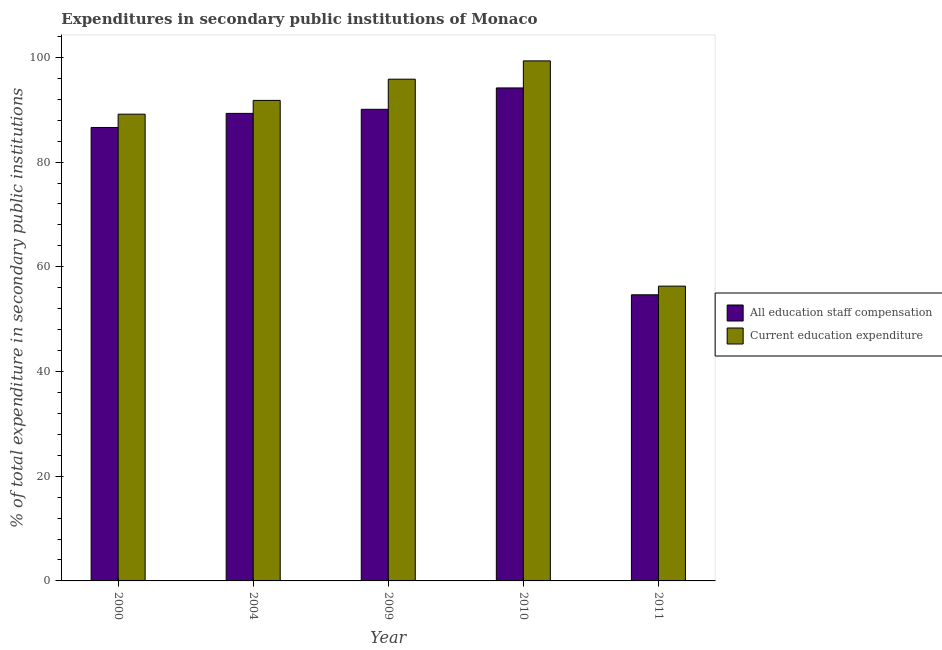How many different coloured bars are there?
Offer a terse response. 2. Are the number of bars per tick equal to the number of legend labels?
Offer a very short reply. Yes. What is the label of the 2nd group of bars from the left?
Make the answer very short. 2004. What is the expenditure in education in 2010?
Ensure brevity in your answer.  99.34. Across all years, what is the maximum expenditure in education?
Ensure brevity in your answer.  99.34. Across all years, what is the minimum expenditure in staff compensation?
Give a very brief answer. 54.66. In which year was the expenditure in staff compensation maximum?
Offer a very short reply. 2010. In which year was the expenditure in education minimum?
Provide a succinct answer. 2011. What is the total expenditure in staff compensation in the graph?
Offer a terse response. 414.84. What is the difference between the expenditure in staff compensation in 2009 and that in 2011?
Provide a succinct answer. 35.43. What is the difference between the expenditure in staff compensation in 2011 and the expenditure in education in 2009?
Provide a succinct answer. -35.43. What is the average expenditure in staff compensation per year?
Offer a terse response. 82.97. What is the ratio of the expenditure in staff compensation in 2000 to that in 2009?
Your answer should be compact. 0.96. Is the expenditure in staff compensation in 2004 less than that in 2011?
Make the answer very short. No. Is the difference between the expenditure in staff compensation in 2000 and 2004 greater than the difference between the expenditure in education in 2000 and 2004?
Provide a succinct answer. No. What is the difference between the highest and the second highest expenditure in education?
Offer a terse response. 3.5. What is the difference between the highest and the lowest expenditure in education?
Provide a short and direct response. 43.03. What does the 2nd bar from the left in 2011 represents?
Offer a very short reply. Current education expenditure. What does the 2nd bar from the right in 2009 represents?
Your answer should be very brief. All education staff compensation. How many bars are there?
Your response must be concise. 10. How many years are there in the graph?
Ensure brevity in your answer.  5. What is the difference between two consecutive major ticks on the Y-axis?
Offer a very short reply. 20. Are the values on the major ticks of Y-axis written in scientific E-notation?
Provide a succinct answer. No. Does the graph contain any zero values?
Make the answer very short. No. Does the graph contain grids?
Provide a succinct answer. No. Where does the legend appear in the graph?
Your answer should be very brief. Center right. How many legend labels are there?
Provide a succinct answer. 2. What is the title of the graph?
Offer a very short reply. Expenditures in secondary public institutions of Monaco. Does "Central government" appear as one of the legend labels in the graph?
Provide a succinct answer. No. What is the label or title of the X-axis?
Your answer should be very brief. Year. What is the label or title of the Y-axis?
Your answer should be compact. % of total expenditure in secondary public institutions. What is the % of total expenditure in secondary public institutions in All education staff compensation in 2000?
Provide a short and direct response. 86.62. What is the % of total expenditure in secondary public institutions of Current education expenditure in 2000?
Make the answer very short. 89.16. What is the % of total expenditure in secondary public institutions in All education staff compensation in 2004?
Provide a succinct answer. 89.31. What is the % of total expenditure in secondary public institutions of Current education expenditure in 2004?
Your answer should be compact. 91.79. What is the % of total expenditure in secondary public institutions in All education staff compensation in 2009?
Your response must be concise. 90.09. What is the % of total expenditure in secondary public institutions in Current education expenditure in 2009?
Offer a very short reply. 95.84. What is the % of total expenditure in secondary public institutions of All education staff compensation in 2010?
Provide a short and direct response. 94.17. What is the % of total expenditure in secondary public institutions of Current education expenditure in 2010?
Ensure brevity in your answer.  99.34. What is the % of total expenditure in secondary public institutions of All education staff compensation in 2011?
Offer a very short reply. 54.66. What is the % of total expenditure in secondary public institutions of Current education expenditure in 2011?
Give a very brief answer. 56.31. Across all years, what is the maximum % of total expenditure in secondary public institutions in All education staff compensation?
Your answer should be very brief. 94.17. Across all years, what is the maximum % of total expenditure in secondary public institutions in Current education expenditure?
Offer a terse response. 99.34. Across all years, what is the minimum % of total expenditure in secondary public institutions of All education staff compensation?
Provide a short and direct response. 54.66. Across all years, what is the minimum % of total expenditure in secondary public institutions of Current education expenditure?
Your answer should be compact. 56.31. What is the total % of total expenditure in secondary public institutions in All education staff compensation in the graph?
Offer a very short reply. 414.84. What is the total % of total expenditure in secondary public institutions in Current education expenditure in the graph?
Make the answer very short. 432.44. What is the difference between the % of total expenditure in secondary public institutions in All education staff compensation in 2000 and that in 2004?
Make the answer very short. -2.69. What is the difference between the % of total expenditure in secondary public institutions of Current education expenditure in 2000 and that in 2004?
Your answer should be compact. -2.63. What is the difference between the % of total expenditure in secondary public institutions in All education staff compensation in 2000 and that in 2009?
Offer a very short reply. -3.47. What is the difference between the % of total expenditure in secondary public institutions of Current education expenditure in 2000 and that in 2009?
Keep it short and to the point. -6.68. What is the difference between the % of total expenditure in secondary public institutions of All education staff compensation in 2000 and that in 2010?
Offer a terse response. -7.55. What is the difference between the % of total expenditure in secondary public institutions in Current education expenditure in 2000 and that in 2010?
Give a very brief answer. -10.18. What is the difference between the % of total expenditure in secondary public institutions in All education staff compensation in 2000 and that in 2011?
Provide a succinct answer. 31.96. What is the difference between the % of total expenditure in secondary public institutions of Current education expenditure in 2000 and that in 2011?
Give a very brief answer. 32.85. What is the difference between the % of total expenditure in secondary public institutions of All education staff compensation in 2004 and that in 2009?
Offer a very short reply. -0.78. What is the difference between the % of total expenditure in secondary public institutions of Current education expenditure in 2004 and that in 2009?
Keep it short and to the point. -4.05. What is the difference between the % of total expenditure in secondary public institutions in All education staff compensation in 2004 and that in 2010?
Ensure brevity in your answer.  -4.86. What is the difference between the % of total expenditure in secondary public institutions of Current education expenditure in 2004 and that in 2010?
Ensure brevity in your answer.  -7.55. What is the difference between the % of total expenditure in secondary public institutions in All education staff compensation in 2004 and that in 2011?
Offer a very short reply. 34.65. What is the difference between the % of total expenditure in secondary public institutions of Current education expenditure in 2004 and that in 2011?
Offer a terse response. 35.48. What is the difference between the % of total expenditure in secondary public institutions in All education staff compensation in 2009 and that in 2010?
Provide a short and direct response. -4.08. What is the difference between the % of total expenditure in secondary public institutions in Current education expenditure in 2009 and that in 2010?
Make the answer very short. -3.5. What is the difference between the % of total expenditure in secondary public institutions of All education staff compensation in 2009 and that in 2011?
Make the answer very short. 35.43. What is the difference between the % of total expenditure in secondary public institutions of Current education expenditure in 2009 and that in 2011?
Offer a very short reply. 39.53. What is the difference between the % of total expenditure in secondary public institutions in All education staff compensation in 2010 and that in 2011?
Provide a succinct answer. 39.51. What is the difference between the % of total expenditure in secondary public institutions of Current education expenditure in 2010 and that in 2011?
Offer a very short reply. 43.03. What is the difference between the % of total expenditure in secondary public institutions in All education staff compensation in 2000 and the % of total expenditure in secondary public institutions in Current education expenditure in 2004?
Give a very brief answer. -5.17. What is the difference between the % of total expenditure in secondary public institutions of All education staff compensation in 2000 and the % of total expenditure in secondary public institutions of Current education expenditure in 2009?
Offer a terse response. -9.23. What is the difference between the % of total expenditure in secondary public institutions of All education staff compensation in 2000 and the % of total expenditure in secondary public institutions of Current education expenditure in 2010?
Offer a terse response. -12.72. What is the difference between the % of total expenditure in secondary public institutions of All education staff compensation in 2000 and the % of total expenditure in secondary public institutions of Current education expenditure in 2011?
Make the answer very short. 30.31. What is the difference between the % of total expenditure in secondary public institutions of All education staff compensation in 2004 and the % of total expenditure in secondary public institutions of Current education expenditure in 2009?
Your answer should be very brief. -6.53. What is the difference between the % of total expenditure in secondary public institutions of All education staff compensation in 2004 and the % of total expenditure in secondary public institutions of Current education expenditure in 2010?
Provide a succinct answer. -10.03. What is the difference between the % of total expenditure in secondary public institutions in All education staff compensation in 2004 and the % of total expenditure in secondary public institutions in Current education expenditure in 2011?
Offer a very short reply. 33. What is the difference between the % of total expenditure in secondary public institutions of All education staff compensation in 2009 and the % of total expenditure in secondary public institutions of Current education expenditure in 2010?
Your answer should be compact. -9.25. What is the difference between the % of total expenditure in secondary public institutions of All education staff compensation in 2009 and the % of total expenditure in secondary public institutions of Current education expenditure in 2011?
Provide a succinct answer. 33.78. What is the difference between the % of total expenditure in secondary public institutions of All education staff compensation in 2010 and the % of total expenditure in secondary public institutions of Current education expenditure in 2011?
Give a very brief answer. 37.86. What is the average % of total expenditure in secondary public institutions of All education staff compensation per year?
Your response must be concise. 82.97. What is the average % of total expenditure in secondary public institutions of Current education expenditure per year?
Your response must be concise. 86.49. In the year 2000, what is the difference between the % of total expenditure in secondary public institutions in All education staff compensation and % of total expenditure in secondary public institutions in Current education expenditure?
Provide a succinct answer. -2.54. In the year 2004, what is the difference between the % of total expenditure in secondary public institutions of All education staff compensation and % of total expenditure in secondary public institutions of Current education expenditure?
Offer a very short reply. -2.48. In the year 2009, what is the difference between the % of total expenditure in secondary public institutions of All education staff compensation and % of total expenditure in secondary public institutions of Current education expenditure?
Provide a succinct answer. -5.75. In the year 2010, what is the difference between the % of total expenditure in secondary public institutions of All education staff compensation and % of total expenditure in secondary public institutions of Current education expenditure?
Offer a terse response. -5.17. In the year 2011, what is the difference between the % of total expenditure in secondary public institutions in All education staff compensation and % of total expenditure in secondary public institutions in Current education expenditure?
Give a very brief answer. -1.65. What is the ratio of the % of total expenditure in secondary public institutions of All education staff compensation in 2000 to that in 2004?
Make the answer very short. 0.97. What is the ratio of the % of total expenditure in secondary public institutions of Current education expenditure in 2000 to that in 2004?
Offer a terse response. 0.97. What is the ratio of the % of total expenditure in secondary public institutions in All education staff compensation in 2000 to that in 2009?
Your answer should be very brief. 0.96. What is the ratio of the % of total expenditure in secondary public institutions of Current education expenditure in 2000 to that in 2009?
Your response must be concise. 0.93. What is the ratio of the % of total expenditure in secondary public institutions of All education staff compensation in 2000 to that in 2010?
Give a very brief answer. 0.92. What is the ratio of the % of total expenditure in secondary public institutions of Current education expenditure in 2000 to that in 2010?
Ensure brevity in your answer.  0.9. What is the ratio of the % of total expenditure in secondary public institutions of All education staff compensation in 2000 to that in 2011?
Ensure brevity in your answer.  1.58. What is the ratio of the % of total expenditure in secondary public institutions of Current education expenditure in 2000 to that in 2011?
Offer a very short reply. 1.58. What is the ratio of the % of total expenditure in secondary public institutions in All education staff compensation in 2004 to that in 2009?
Give a very brief answer. 0.99. What is the ratio of the % of total expenditure in secondary public institutions of Current education expenditure in 2004 to that in 2009?
Your response must be concise. 0.96. What is the ratio of the % of total expenditure in secondary public institutions of All education staff compensation in 2004 to that in 2010?
Make the answer very short. 0.95. What is the ratio of the % of total expenditure in secondary public institutions in Current education expenditure in 2004 to that in 2010?
Give a very brief answer. 0.92. What is the ratio of the % of total expenditure in secondary public institutions of All education staff compensation in 2004 to that in 2011?
Give a very brief answer. 1.63. What is the ratio of the % of total expenditure in secondary public institutions of Current education expenditure in 2004 to that in 2011?
Provide a succinct answer. 1.63. What is the ratio of the % of total expenditure in secondary public institutions of All education staff compensation in 2009 to that in 2010?
Make the answer very short. 0.96. What is the ratio of the % of total expenditure in secondary public institutions of Current education expenditure in 2009 to that in 2010?
Your answer should be very brief. 0.96. What is the ratio of the % of total expenditure in secondary public institutions in All education staff compensation in 2009 to that in 2011?
Ensure brevity in your answer.  1.65. What is the ratio of the % of total expenditure in secondary public institutions of Current education expenditure in 2009 to that in 2011?
Ensure brevity in your answer.  1.7. What is the ratio of the % of total expenditure in secondary public institutions of All education staff compensation in 2010 to that in 2011?
Ensure brevity in your answer.  1.72. What is the ratio of the % of total expenditure in secondary public institutions in Current education expenditure in 2010 to that in 2011?
Provide a succinct answer. 1.76. What is the difference between the highest and the second highest % of total expenditure in secondary public institutions of All education staff compensation?
Provide a short and direct response. 4.08. What is the difference between the highest and the second highest % of total expenditure in secondary public institutions of Current education expenditure?
Provide a succinct answer. 3.5. What is the difference between the highest and the lowest % of total expenditure in secondary public institutions in All education staff compensation?
Your answer should be compact. 39.51. What is the difference between the highest and the lowest % of total expenditure in secondary public institutions of Current education expenditure?
Your answer should be very brief. 43.03. 